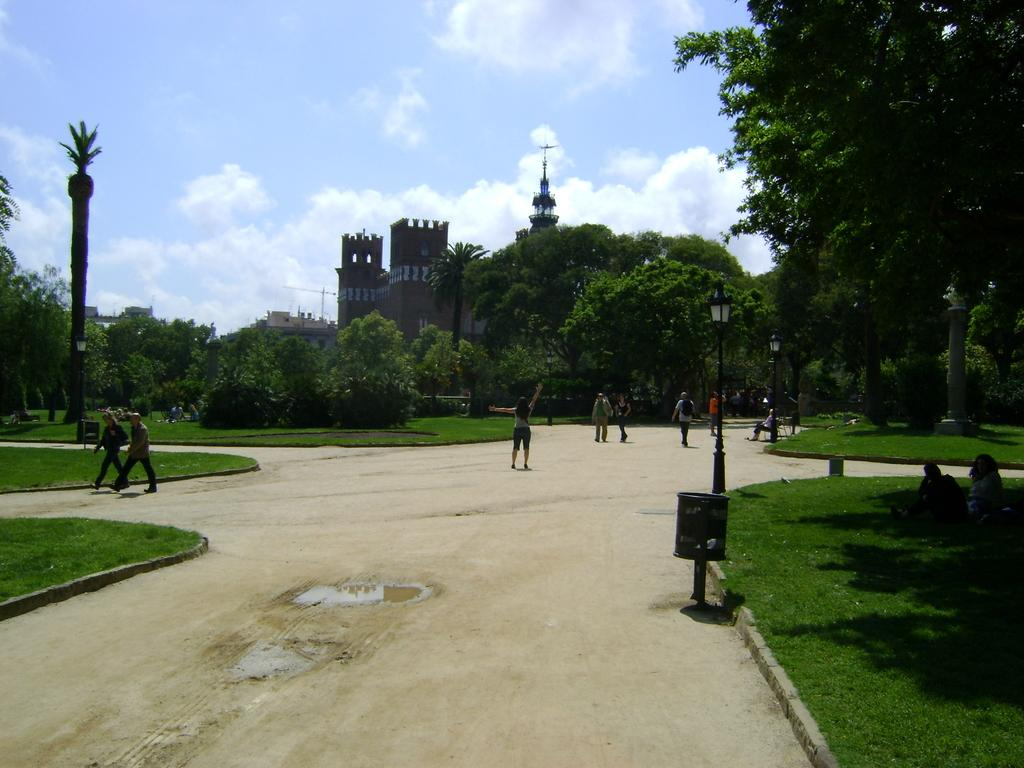What type of location is depicted in the image? The image appears to depict a park. What can be seen in the park? There are trees in the image. What are the two persons on the left side of the image doing? They are walking. What structures are visible in the middle of the image? There are buildings in the middle of the image. What type of vest is the donkey wearing in the image? There is no donkey present in the image, and therefore no vest can be observed. How many balls are visible in the image? There are no balls present in the image. 